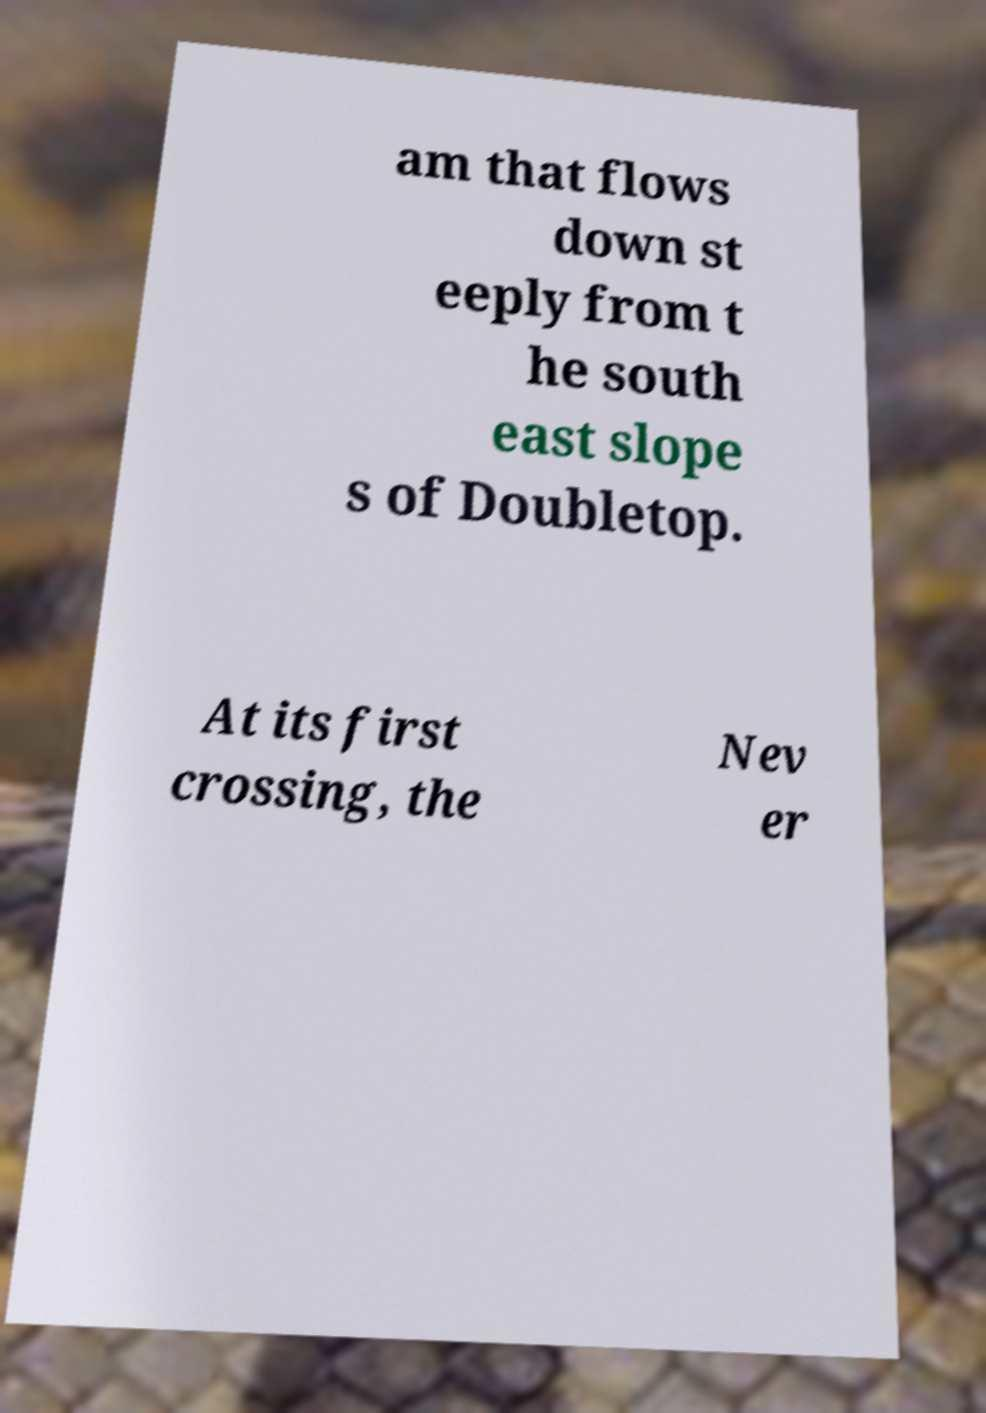Can you accurately transcribe the text from the provided image for me? am that flows down st eeply from t he south east slope s of Doubletop. At its first crossing, the Nev er 